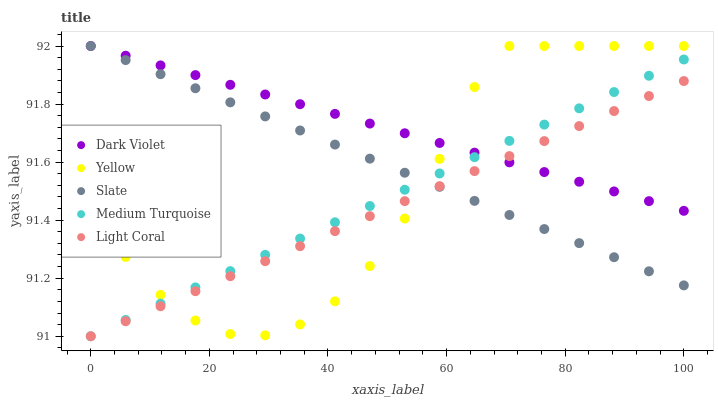Does Light Coral have the minimum area under the curve?
Answer yes or no. Yes. Does Dark Violet have the maximum area under the curve?
Answer yes or no. Yes. Does Slate have the minimum area under the curve?
Answer yes or no. No. Does Slate have the maximum area under the curve?
Answer yes or no. No. Is Slate the smoothest?
Answer yes or no. Yes. Is Yellow the roughest?
Answer yes or no. Yes. Is Yellow the smoothest?
Answer yes or no. No. Is Slate the roughest?
Answer yes or no. No. Does Light Coral have the lowest value?
Answer yes or no. Yes. Does Slate have the lowest value?
Answer yes or no. No. Does Dark Violet have the highest value?
Answer yes or no. Yes. Does Medium Turquoise have the highest value?
Answer yes or no. No. Does Light Coral intersect Medium Turquoise?
Answer yes or no. Yes. Is Light Coral less than Medium Turquoise?
Answer yes or no. No. Is Light Coral greater than Medium Turquoise?
Answer yes or no. No. 